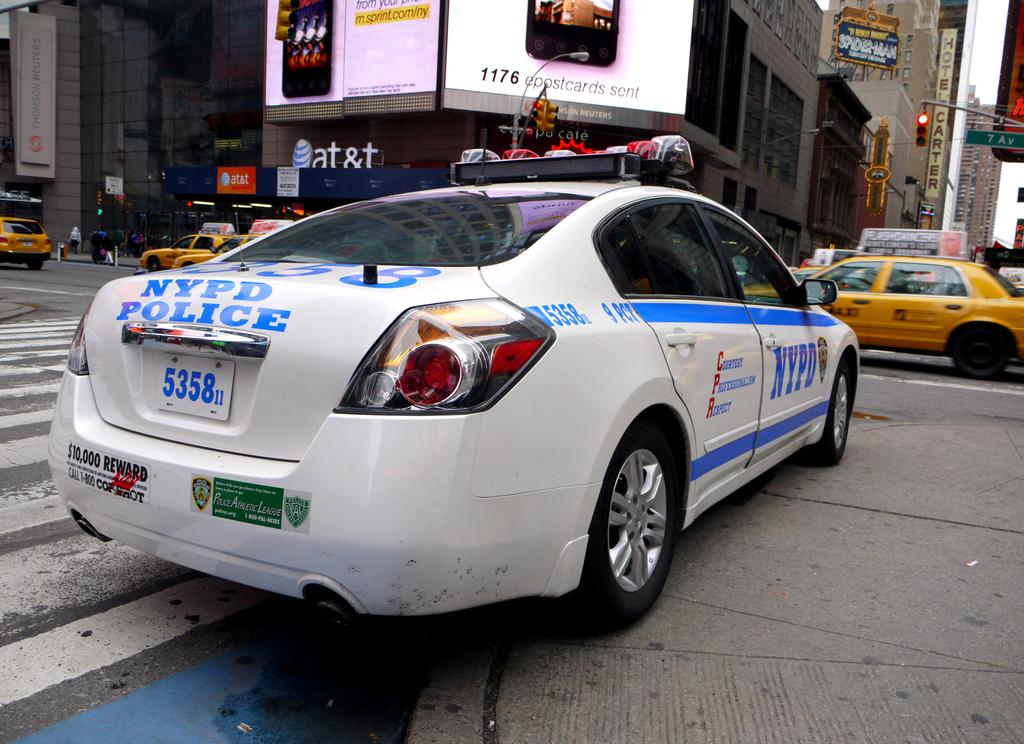<image>
Write a terse but informative summary of the picture. An NYPD Police car license #5358 sits in a crosswalk in front of an AT&T ad. 